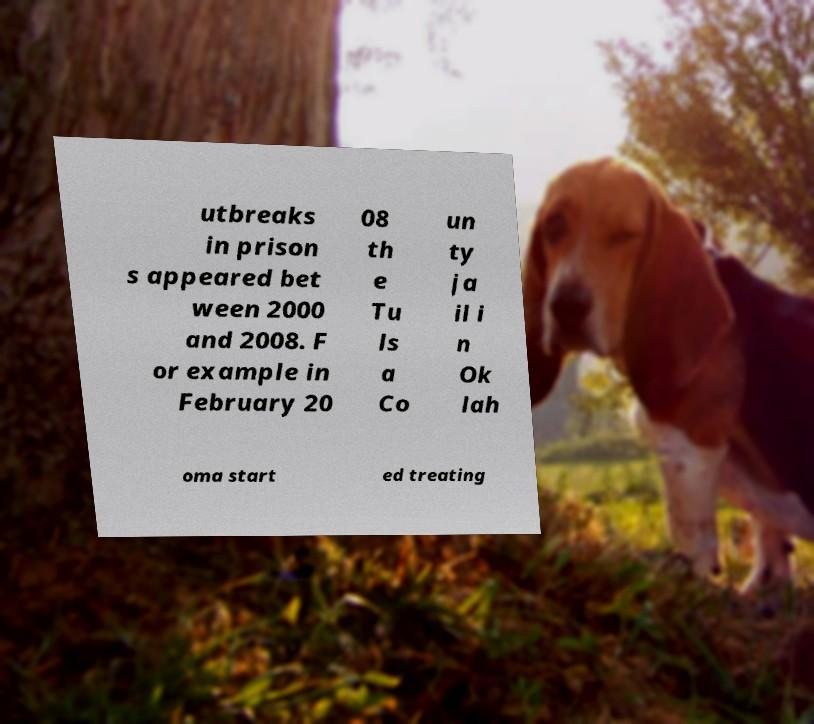Can you read and provide the text displayed in the image?This photo seems to have some interesting text. Can you extract and type it out for me? utbreaks in prison s appeared bet ween 2000 and 2008. F or example in February 20 08 th e Tu ls a Co un ty ja il i n Ok lah oma start ed treating 